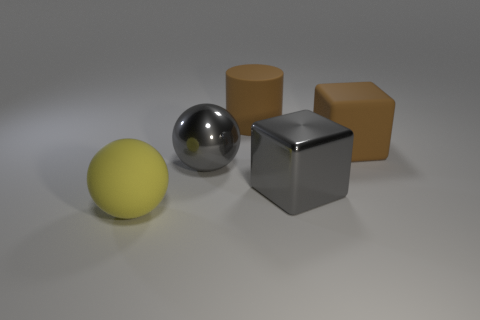What is the big thing that is both to the left of the big cylinder and behind the yellow ball made of?
Give a very brief answer. Metal. Is the big brown cube made of the same material as the gray object that is to the left of the large matte cylinder?
Offer a very short reply. No. Are there any other things that have the same size as the yellow sphere?
Give a very brief answer. Yes. What number of things are shiny cubes or objects on the left side of the big gray shiny ball?
Make the answer very short. 2. Do the gray metal thing left of the big cylinder and the cube behind the big shiny ball have the same size?
Keep it short and to the point. Yes. What number of other objects are there of the same color as the cylinder?
Your answer should be very brief. 1. There is a cylinder; is its size the same as the yellow thing to the left of the large brown cube?
Offer a very short reply. Yes. There is a matte object that is on the left side of the large sphere right of the large yellow thing; what is its size?
Your answer should be compact. Large. What is the color of the other thing that is the same shape as the yellow object?
Your answer should be compact. Gray. Is the cylinder the same size as the yellow matte thing?
Provide a short and direct response. Yes. 